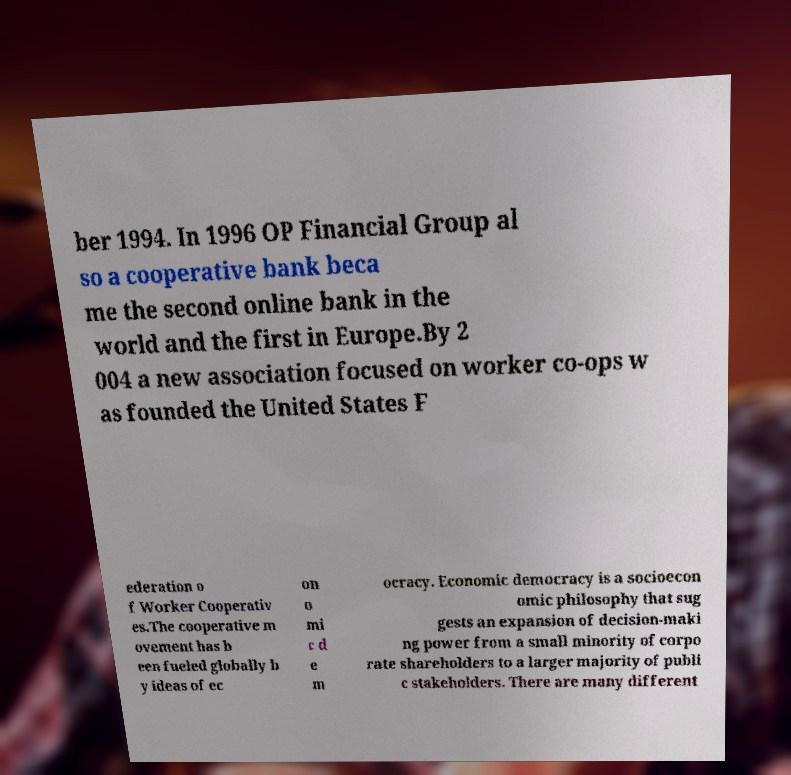What messages or text are displayed in this image? I need them in a readable, typed format. ber 1994. In 1996 OP Financial Group al so a cooperative bank beca me the second online bank in the world and the first in Europe.By 2 004 a new association focused on worker co-ops w as founded the United States F ederation o f Worker Cooperativ es.The cooperative m ovement has b een fueled globally b y ideas of ec on o mi c d e m ocracy. Economic democracy is a socioecon omic philosophy that sug gests an expansion of decision-maki ng power from a small minority of corpo rate shareholders to a larger majority of publi c stakeholders. There are many different 